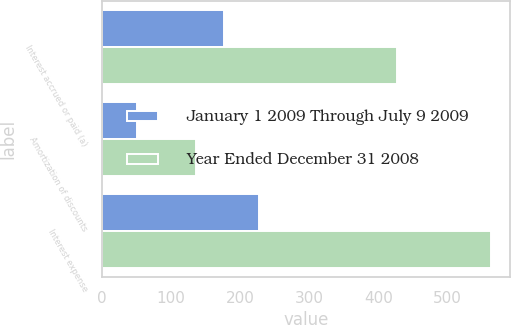Convert chart to OTSL. <chart><loc_0><loc_0><loc_500><loc_500><stacked_bar_chart><ecel><fcel>Interest accrued or paid (a)<fcel>Amortization of discounts<fcel>Interest expense<nl><fcel>January 1 2009 Through July 9 2009<fcel>176<fcel>51<fcel>227<nl><fcel>Year Ended December 31 2008<fcel>427<fcel>136<fcel>563<nl></chart> 